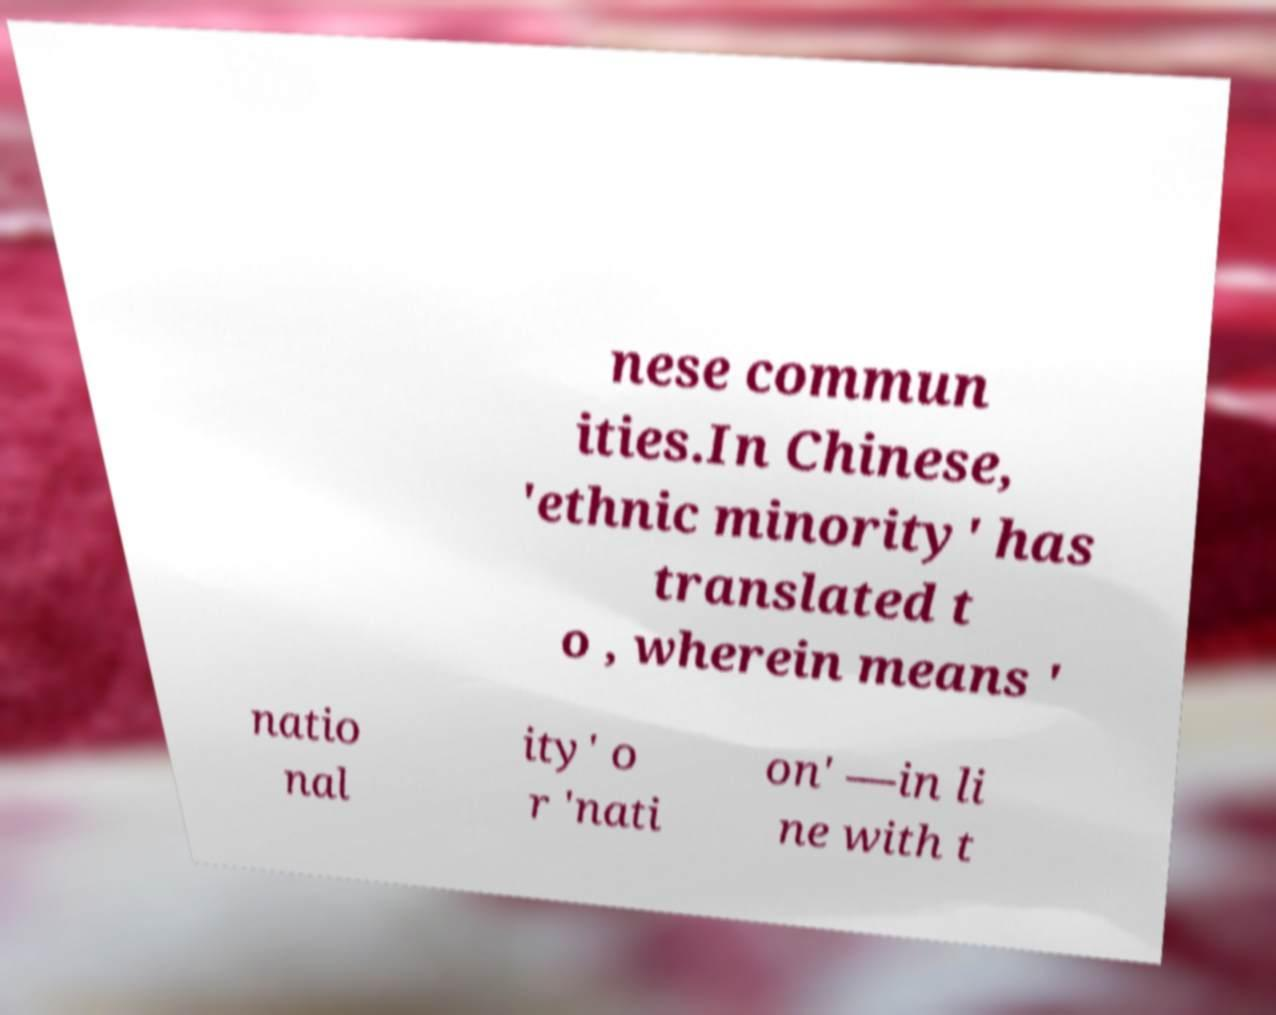What messages or text are displayed in this image? I need them in a readable, typed format. nese commun ities.In Chinese, 'ethnic minority' has translated t o , wherein means ' natio nal ity' o r 'nati on' —in li ne with t 